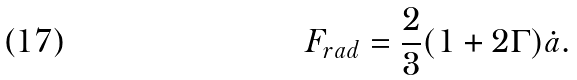Convert formula to latex. <formula><loc_0><loc_0><loc_500><loc_500>F _ { r a d } = \frac { 2 } { 3 } ( 1 + 2 \Gamma ) \dot { a } \text {.}</formula> 